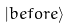<formula> <loc_0><loc_0><loc_500><loc_500>| { b e f o r e } \rangle</formula> 